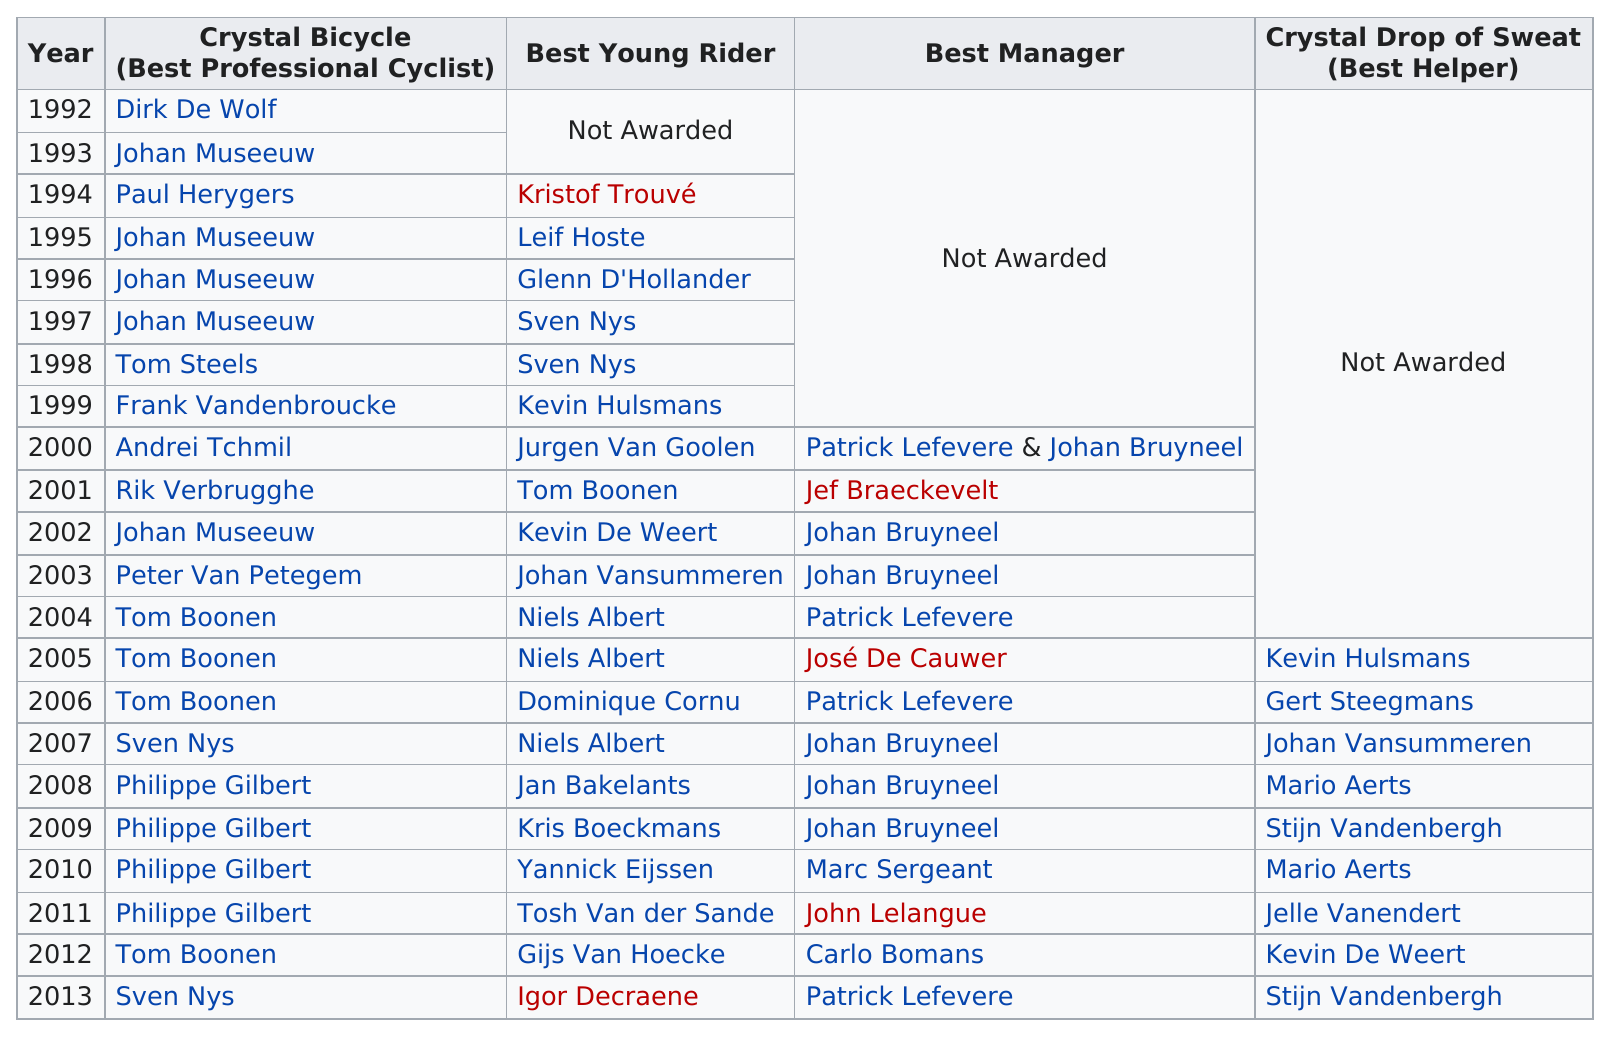Specify some key components in this picture. Johan Museeuw was starred an average of 5 times. Dirk De Wolf is the cyclist who is listed at the earliest date. Niels Albert is the cyclist who has won the most best young rider awards. Philippe Gilbert has won the Crystal Bicycle Award four times. Philippe Gilbert is the person who won the most consecutive crystal bicycles. 